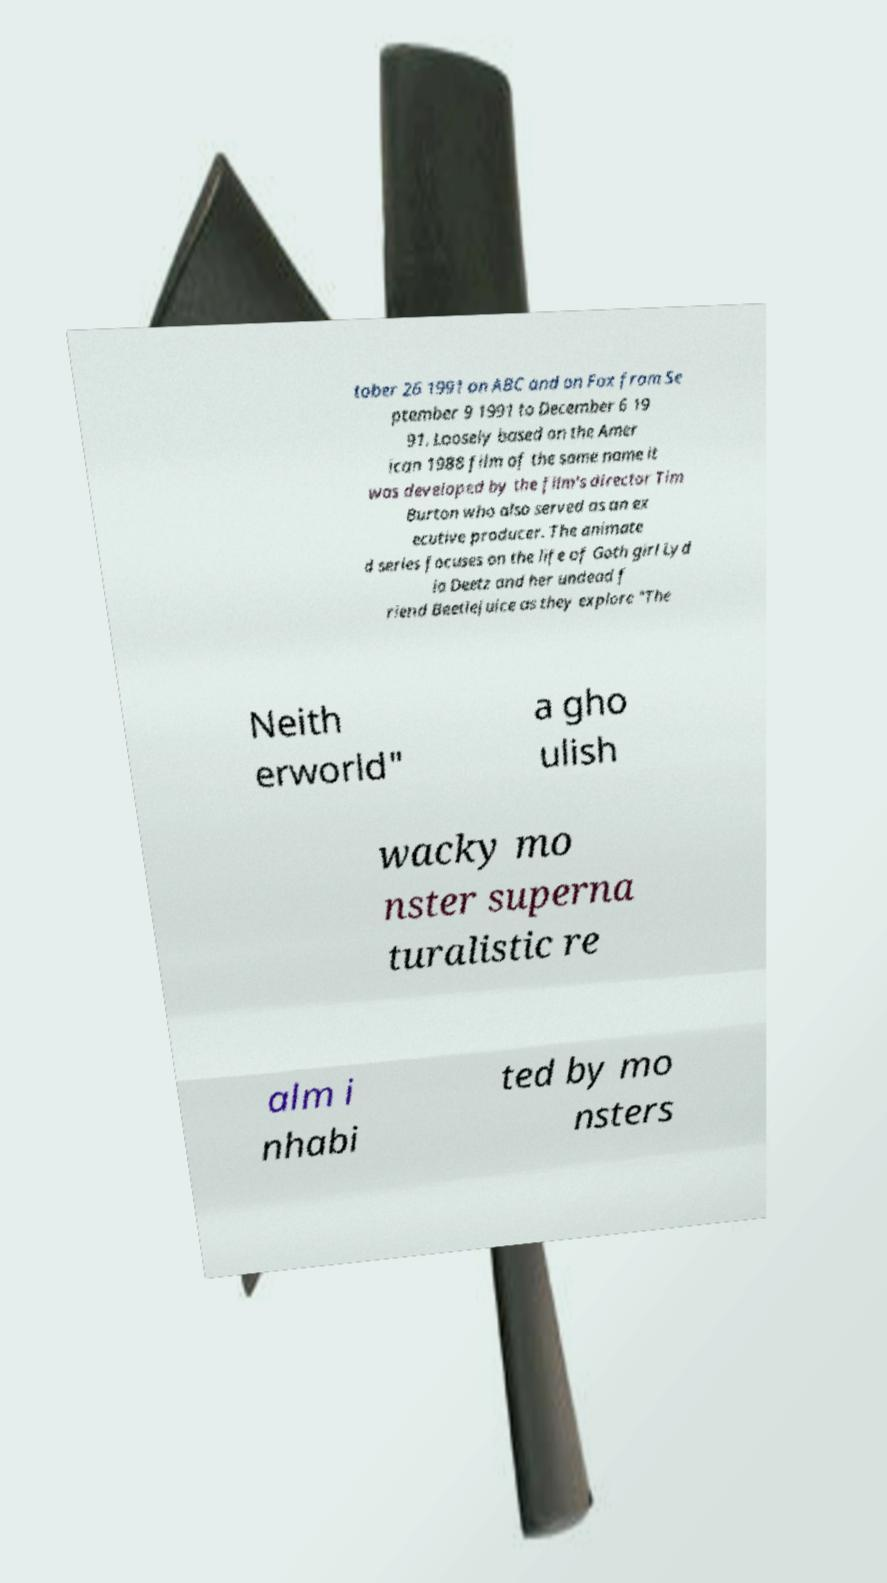There's text embedded in this image that I need extracted. Can you transcribe it verbatim? tober 26 1991 on ABC and on Fox from Se ptember 9 1991 to December 6 19 91. Loosely based on the Amer ican 1988 film of the same name it was developed by the film's director Tim Burton who also served as an ex ecutive producer. The animate d series focuses on the life of Goth girl Lyd ia Deetz and her undead f riend Beetlejuice as they explore "The Neith erworld" a gho ulish wacky mo nster superna turalistic re alm i nhabi ted by mo nsters 